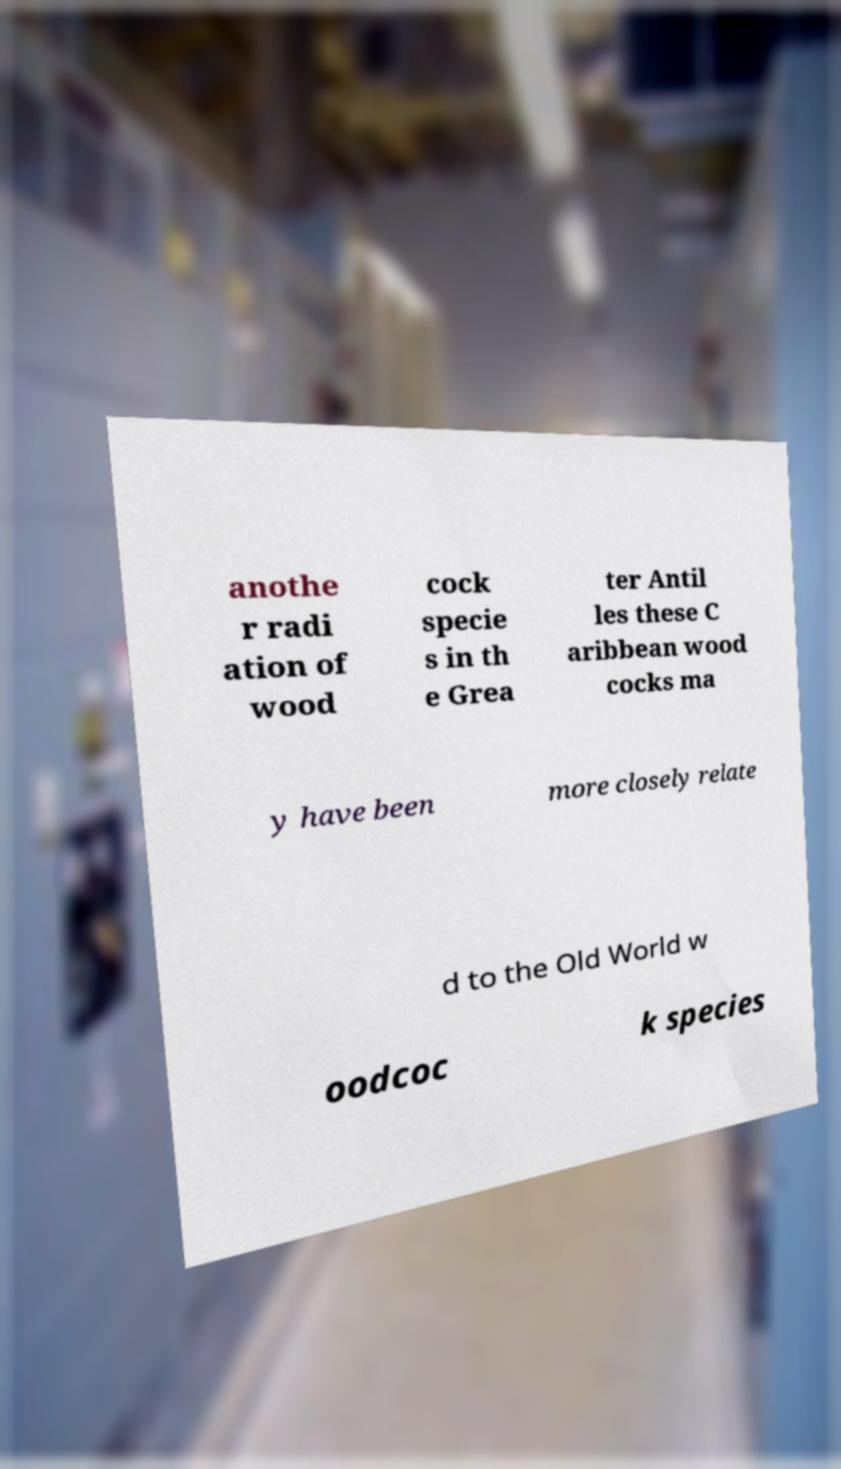There's text embedded in this image that I need extracted. Can you transcribe it verbatim? anothe r radi ation of wood cock specie s in th e Grea ter Antil les these C aribbean wood cocks ma y have been more closely relate d to the Old World w oodcoc k species 